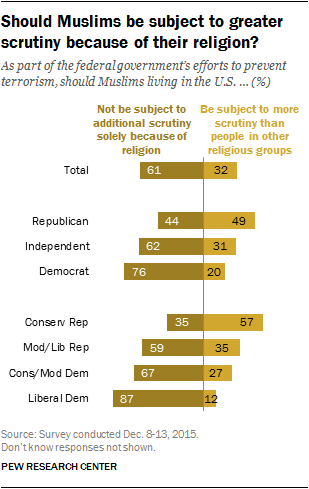Highlight a few significant elements in this photo. The group that thought they should not be objected to it all the most were the Liberal Democrats. The difference between the total of all the groups' responses was 0.29. 